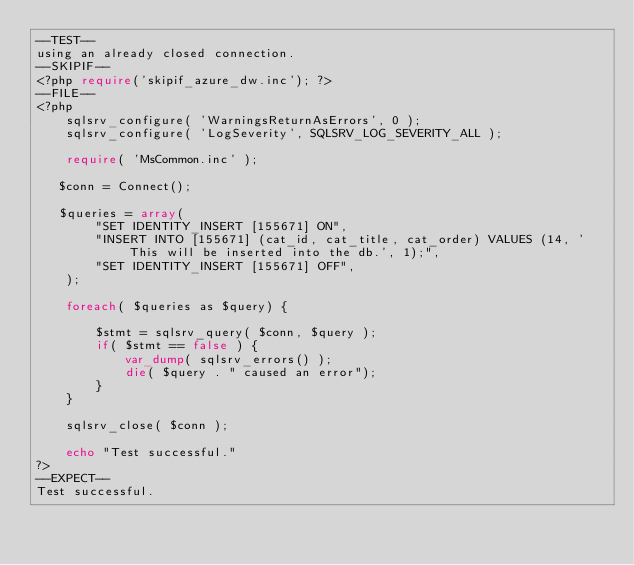Convert code to text. <code><loc_0><loc_0><loc_500><loc_500><_PHP_>--TEST--
using an already closed connection.
--SKIPIF--
<?php require('skipif_azure_dw.inc'); ?>
--FILE--
<?php
    sqlsrv_configure( 'WarningsReturnAsErrors', 0 );
    sqlsrv_configure( 'LogSeverity', SQLSRV_LOG_SEVERITY_ALL );

    require( 'MsCommon.inc' );

   $conn = Connect();
   
   $queries = array(
        "SET IDENTITY_INSERT [155671] ON",
        "INSERT INTO [155671] (cat_id, cat_title, cat_order) VALUES (14, 'This will be inserted into the db.', 1);",
        "SET IDENTITY_INSERT [155671] OFF",
    );
    
    foreach( $queries as $query) {
    
        $stmt = sqlsrv_query( $conn, $query );
        if( $stmt == false ) {
            var_dump( sqlsrv_errors() );
            die( $query . " caused an error");
        }
    }
    
    sqlsrv_close( $conn );

    echo "Test successful."
?>
--EXPECT--
Test successful.
</code> 